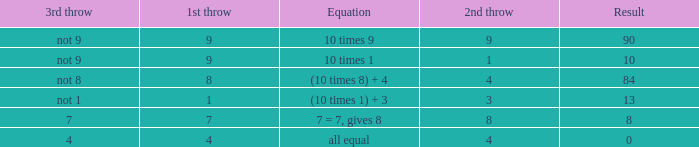What is the result when the 3rd throw is not 8? 84.0. 